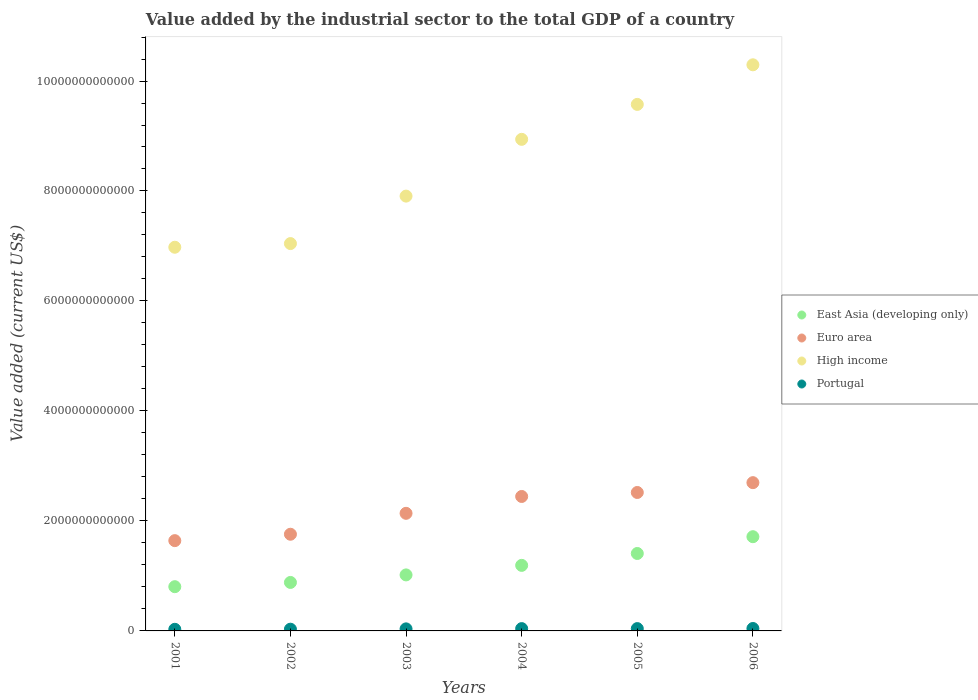What is the value added by the industrial sector to the total GDP in East Asia (developing only) in 2005?
Offer a very short reply. 1.41e+12. Across all years, what is the maximum value added by the industrial sector to the total GDP in Portugal?
Keep it short and to the point. 4.41e+1. Across all years, what is the minimum value added by the industrial sector to the total GDP in High income?
Provide a succinct answer. 6.98e+12. In which year was the value added by the industrial sector to the total GDP in Portugal maximum?
Offer a terse response. 2006. In which year was the value added by the industrial sector to the total GDP in Portugal minimum?
Your answer should be compact. 2001. What is the total value added by the industrial sector to the total GDP in East Asia (developing only) in the graph?
Offer a very short reply. 7.02e+12. What is the difference between the value added by the industrial sector to the total GDP in High income in 2003 and that in 2004?
Ensure brevity in your answer.  -1.03e+12. What is the difference between the value added by the industrial sector to the total GDP in East Asia (developing only) in 2004 and the value added by the industrial sector to the total GDP in High income in 2001?
Give a very brief answer. -5.78e+12. What is the average value added by the industrial sector to the total GDP in Portugal per year?
Ensure brevity in your answer.  3.77e+1. In the year 2003, what is the difference between the value added by the industrial sector to the total GDP in High income and value added by the industrial sector to the total GDP in Euro area?
Provide a succinct answer. 5.77e+12. In how many years, is the value added by the industrial sector to the total GDP in Portugal greater than 400000000000 US$?
Your answer should be compact. 0. What is the ratio of the value added by the industrial sector to the total GDP in Euro area in 2003 to that in 2005?
Give a very brief answer. 0.85. Is the value added by the industrial sector to the total GDP in Euro area in 2001 less than that in 2002?
Provide a short and direct response. Yes. What is the difference between the highest and the second highest value added by the industrial sector to the total GDP in Portugal?
Your answer should be very brief. 1.95e+09. What is the difference between the highest and the lowest value added by the industrial sector to the total GDP in High income?
Offer a terse response. 3.32e+12. Does the value added by the industrial sector to the total GDP in Portugal monotonically increase over the years?
Your answer should be compact. Yes. Is the value added by the industrial sector to the total GDP in East Asia (developing only) strictly less than the value added by the industrial sector to the total GDP in Portugal over the years?
Offer a very short reply. No. How many years are there in the graph?
Make the answer very short. 6. What is the difference between two consecutive major ticks on the Y-axis?
Offer a terse response. 2.00e+12. Does the graph contain any zero values?
Ensure brevity in your answer.  No. Where does the legend appear in the graph?
Your response must be concise. Center right. How many legend labels are there?
Provide a short and direct response. 4. How are the legend labels stacked?
Provide a short and direct response. Vertical. What is the title of the graph?
Offer a terse response. Value added by the industrial sector to the total GDP of a country. What is the label or title of the Y-axis?
Provide a succinct answer. Value added (current US$). What is the Value added (current US$) in East Asia (developing only) in 2001?
Offer a terse response. 8.04e+11. What is the Value added (current US$) in Euro area in 2001?
Provide a short and direct response. 1.64e+12. What is the Value added (current US$) of High income in 2001?
Provide a short and direct response. 6.98e+12. What is the Value added (current US$) of Portugal in 2001?
Your answer should be very brief. 2.93e+1. What is the Value added (current US$) in East Asia (developing only) in 2002?
Your answer should be compact. 8.82e+11. What is the Value added (current US$) of Euro area in 2002?
Your answer should be compact. 1.76e+12. What is the Value added (current US$) of High income in 2002?
Your response must be concise. 7.04e+12. What is the Value added (current US$) of Portugal in 2002?
Your answer should be very brief. 3.15e+1. What is the Value added (current US$) of East Asia (developing only) in 2003?
Your answer should be very brief. 1.02e+12. What is the Value added (current US$) in Euro area in 2003?
Keep it short and to the point. 2.14e+12. What is the Value added (current US$) in High income in 2003?
Your response must be concise. 7.91e+12. What is the Value added (current US$) of Portugal in 2003?
Your answer should be very brief. 3.73e+1. What is the Value added (current US$) of East Asia (developing only) in 2004?
Your answer should be very brief. 1.19e+12. What is the Value added (current US$) of Euro area in 2004?
Your response must be concise. 2.44e+12. What is the Value added (current US$) of High income in 2004?
Make the answer very short. 8.94e+12. What is the Value added (current US$) in Portugal in 2004?
Provide a succinct answer. 4.20e+1. What is the Value added (current US$) in East Asia (developing only) in 2005?
Your response must be concise. 1.41e+12. What is the Value added (current US$) in Euro area in 2005?
Your answer should be compact. 2.52e+12. What is the Value added (current US$) of High income in 2005?
Offer a terse response. 9.57e+12. What is the Value added (current US$) of Portugal in 2005?
Keep it short and to the point. 4.22e+1. What is the Value added (current US$) in East Asia (developing only) in 2006?
Give a very brief answer. 1.71e+12. What is the Value added (current US$) of Euro area in 2006?
Offer a terse response. 2.70e+12. What is the Value added (current US$) of High income in 2006?
Ensure brevity in your answer.  1.03e+13. What is the Value added (current US$) of Portugal in 2006?
Provide a short and direct response. 4.41e+1. Across all years, what is the maximum Value added (current US$) in East Asia (developing only)?
Provide a short and direct response. 1.71e+12. Across all years, what is the maximum Value added (current US$) in Euro area?
Ensure brevity in your answer.  2.70e+12. Across all years, what is the maximum Value added (current US$) in High income?
Keep it short and to the point. 1.03e+13. Across all years, what is the maximum Value added (current US$) in Portugal?
Keep it short and to the point. 4.41e+1. Across all years, what is the minimum Value added (current US$) of East Asia (developing only)?
Provide a succinct answer. 8.04e+11. Across all years, what is the minimum Value added (current US$) in Euro area?
Give a very brief answer. 1.64e+12. Across all years, what is the minimum Value added (current US$) in High income?
Provide a short and direct response. 6.98e+12. Across all years, what is the minimum Value added (current US$) in Portugal?
Ensure brevity in your answer.  2.93e+1. What is the total Value added (current US$) of East Asia (developing only) in the graph?
Provide a short and direct response. 7.02e+12. What is the total Value added (current US$) of Euro area in the graph?
Provide a short and direct response. 1.32e+13. What is the total Value added (current US$) in High income in the graph?
Keep it short and to the point. 5.07e+13. What is the total Value added (current US$) in Portugal in the graph?
Provide a succinct answer. 2.26e+11. What is the difference between the Value added (current US$) in East Asia (developing only) in 2001 and that in 2002?
Give a very brief answer. -7.72e+1. What is the difference between the Value added (current US$) in Euro area in 2001 and that in 2002?
Your response must be concise. -1.16e+11. What is the difference between the Value added (current US$) in High income in 2001 and that in 2002?
Make the answer very short. -6.67e+1. What is the difference between the Value added (current US$) of Portugal in 2001 and that in 2002?
Give a very brief answer. -2.19e+09. What is the difference between the Value added (current US$) in East Asia (developing only) in 2001 and that in 2003?
Offer a terse response. -2.14e+11. What is the difference between the Value added (current US$) of Euro area in 2001 and that in 2003?
Your response must be concise. -4.97e+11. What is the difference between the Value added (current US$) in High income in 2001 and that in 2003?
Ensure brevity in your answer.  -9.30e+11. What is the difference between the Value added (current US$) in Portugal in 2001 and that in 2003?
Ensure brevity in your answer.  -7.97e+09. What is the difference between the Value added (current US$) of East Asia (developing only) in 2001 and that in 2004?
Ensure brevity in your answer.  -3.88e+11. What is the difference between the Value added (current US$) of Euro area in 2001 and that in 2004?
Keep it short and to the point. -8.03e+11. What is the difference between the Value added (current US$) in High income in 2001 and that in 2004?
Ensure brevity in your answer.  -1.96e+12. What is the difference between the Value added (current US$) in Portugal in 2001 and that in 2004?
Your answer should be very brief. -1.27e+1. What is the difference between the Value added (current US$) of East Asia (developing only) in 2001 and that in 2005?
Your answer should be compact. -6.04e+11. What is the difference between the Value added (current US$) of Euro area in 2001 and that in 2005?
Your answer should be compact. -8.76e+11. What is the difference between the Value added (current US$) of High income in 2001 and that in 2005?
Offer a terse response. -2.60e+12. What is the difference between the Value added (current US$) in Portugal in 2001 and that in 2005?
Offer a very short reply. -1.28e+1. What is the difference between the Value added (current US$) of East Asia (developing only) in 2001 and that in 2006?
Provide a short and direct response. -9.09e+11. What is the difference between the Value added (current US$) in Euro area in 2001 and that in 2006?
Provide a succinct answer. -1.05e+12. What is the difference between the Value added (current US$) of High income in 2001 and that in 2006?
Keep it short and to the point. -3.32e+12. What is the difference between the Value added (current US$) in Portugal in 2001 and that in 2006?
Keep it short and to the point. -1.48e+1. What is the difference between the Value added (current US$) of East Asia (developing only) in 2002 and that in 2003?
Your answer should be very brief. -1.37e+11. What is the difference between the Value added (current US$) of Euro area in 2002 and that in 2003?
Offer a terse response. -3.80e+11. What is the difference between the Value added (current US$) in High income in 2002 and that in 2003?
Your answer should be very brief. -8.63e+11. What is the difference between the Value added (current US$) in Portugal in 2002 and that in 2003?
Ensure brevity in your answer.  -5.78e+09. What is the difference between the Value added (current US$) of East Asia (developing only) in 2002 and that in 2004?
Give a very brief answer. -3.10e+11. What is the difference between the Value added (current US$) in Euro area in 2002 and that in 2004?
Give a very brief answer. -6.87e+11. What is the difference between the Value added (current US$) in High income in 2002 and that in 2004?
Your response must be concise. -1.90e+12. What is the difference between the Value added (current US$) in Portugal in 2002 and that in 2004?
Give a very brief answer. -1.05e+1. What is the difference between the Value added (current US$) in East Asia (developing only) in 2002 and that in 2005?
Offer a very short reply. -5.27e+11. What is the difference between the Value added (current US$) of Euro area in 2002 and that in 2005?
Provide a succinct answer. -7.59e+11. What is the difference between the Value added (current US$) in High income in 2002 and that in 2005?
Make the answer very short. -2.53e+12. What is the difference between the Value added (current US$) of Portugal in 2002 and that in 2005?
Your response must be concise. -1.06e+1. What is the difference between the Value added (current US$) of East Asia (developing only) in 2002 and that in 2006?
Provide a succinct answer. -8.32e+11. What is the difference between the Value added (current US$) in Euro area in 2002 and that in 2006?
Make the answer very short. -9.38e+11. What is the difference between the Value added (current US$) of High income in 2002 and that in 2006?
Offer a very short reply. -3.25e+12. What is the difference between the Value added (current US$) of Portugal in 2002 and that in 2006?
Provide a short and direct response. -1.26e+1. What is the difference between the Value added (current US$) in East Asia (developing only) in 2003 and that in 2004?
Your answer should be very brief. -1.73e+11. What is the difference between the Value added (current US$) in Euro area in 2003 and that in 2004?
Your response must be concise. -3.06e+11. What is the difference between the Value added (current US$) in High income in 2003 and that in 2004?
Your response must be concise. -1.03e+12. What is the difference between the Value added (current US$) in Portugal in 2003 and that in 2004?
Provide a short and direct response. -4.73e+09. What is the difference between the Value added (current US$) of East Asia (developing only) in 2003 and that in 2005?
Provide a succinct answer. -3.90e+11. What is the difference between the Value added (current US$) of Euro area in 2003 and that in 2005?
Offer a terse response. -3.79e+11. What is the difference between the Value added (current US$) in High income in 2003 and that in 2005?
Make the answer very short. -1.67e+12. What is the difference between the Value added (current US$) of Portugal in 2003 and that in 2005?
Provide a short and direct response. -4.85e+09. What is the difference between the Value added (current US$) in East Asia (developing only) in 2003 and that in 2006?
Your response must be concise. -6.95e+11. What is the difference between the Value added (current US$) in Euro area in 2003 and that in 2006?
Offer a very short reply. -5.58e+11. What is the difference between the Value added (current US$) in High income in 2003 and that in 2006?
Make the answer very short. -2.39e+12. What is the difference between the Value added (current US$) of Portugal in 2003 and that in 2006?
Offer a very short reply. -6.80e+09. What is the difference between the Value added (current US$) in East Asia (developing only) in 2004 and that in 2005?
Keep it short and to the point. -2.16e+11. What is the difference between the Value added (current US$) in Euro area in 2004 and that in 2005?
Offer a very short reply. -7.26e+1. What is the difference between the Value added (current US$) in High income in 2004 and that in 2005?
Provide a succinct answer. -6.35e+11. What is the difference between the Value added (current US$) in Portugal in 2004 and that in 2005?
Your answer should be compact. -1.28e+08. What is the difference between the Value added (current US$) in East Asia (developing only) in 2004 and that in 2006?
Provide a short and direct response. -5.21e+11. What is the difference between the Value added (current US$) in Euro area in 2004 and that in 2006?
Provide a short and direct response. -2.51e+11. What is the difference between the Value added (current US$) in High income in 2004 and that in 2006?
Provide a succinct answer. -1.36e+12. What is the difference between the Value added (current US$) in Portugal in 2004 and that in 2006?
Your response must be concise. -2.07e+09. What is the difference between the Value added (current US$) in East Asia (developing only) in 2005 and that in 2006?
Offer a very short reply. -3.05e+11. What is the difference between the Value added (current US$) in Euro area in 2005 and that in 2006?
Provide a succinct answer. -1.79e+11. What is the difference between the Value added (current US$) in High income in 2005 and that in 2006?
Offer a very short reply. -7.20e+11. What is the difference between the Value added (current US$) of Portugal in 2005 and that in 2006?
Your answer should be very brief. -1.95e+09. What is the difference between the Value added (current US$) in East Asia (developing only) in 2001 and the Value added (current US$) in Euro area in 2002?
Make the answer very short. -9.54e+11. What is the difference between the Value added (current US$) in East Asia (developing only) in 2001 and the Value added (current US$) in High income in 2002?
Provide a short and direct response. -6.24e+12. What is the difference between the Value added (current US$) in East Asia (developing only) in 2001 and the Value added (current US$) in Portugal in 2002?
Your answer should be very brief. 7.73e+11. What is the difference between the Value added (current US$) of Euro area in 2001 and the Value added (current US$) of High income in 2002?
Your response must be concise. -5.40e+12. What is the difference between the Value added (current US$) of Euro area in 2001 and the Value added (current US$) of Portugal in 2002?
Provide a succinct answer. 1.61e+12. What is the difference between the Value added (current US$) in High income in 2001 and the Value added (current US$) in Portugal in 2002?
Your answer should be very brief. 6.95e+12. What is the difference between the Value added (current US$) in East Asia (developing only) in 2001 and the Value added (current US$) in Euro area in 2003?
Provide a short and direct response. -1.33e+12. What is the difference between the Value added (current US$) in East Asia (developing only) in 2001 and the Value added (current US$) in High income in 2003?
Provide a succinct answer. -7.10e+12. What is the difference between the Value added (current US$) of East Asia (developing only) in 2001 and the Value added (current US$) of Portugal in 2003?
Ensure brevity in your answer.  7.67e+11. What is the difference between the Value added (current US$) in Euro area in 2001 and the Value added (current US$) in High income in 2003?
Provide a succinct answer. -6.27e+12. What is the difference between the Value added (current US$) in Euro area in 2001 and the Value added (current US$) in Portugal in 2003?
Your response must be concise. 1.60e+12. What is the difference between the Value added (current US$) in High income in 2001 and the Value added (current US$) in Portugal in 2003?
Your answer should be very brief. 6.94e+12. What is the difference between the Value added (current US$) of East Asia (developing only) in 2001 and the Value added (current US$) of Euro area in 2004?
Give a very brief answer. -1.64e+12. What is the difference between the Value added (current US$) of East Asia (developing only) in 2001 and the Value added (current US$) of High income in 2004?
Your answer should be very brief. -8.13e+12. What is the difference between the Value added (current US$) in East Asia (developing only) in 2001 and the Value added (current US$) in Portugal in 2004?
Your answer should be very brief. 7.62e+11. What is the difference between the Value added (current US$) in Euro area in 2001 and the Value added (current US$) in High income in 2004?
Provide a short and direct response. -7.30e+12. What is the difference between the Value added (current US$) of Euro area in 2001 and the Value added (current US$) of Portugal in 2004?
Make the answer very short. 1.60e+12. What is the difference between the Value added (current US$) in High income in 2001 and the Value added (current US$) in Portugal in 2004?
Keep it short and to the point. 6.93e+12. What is the difference between the Value added (current US$) in East Asia (developing only) in 2001 and the Value added (current US$) in Euro area in 2005?
Make the answer very short. -1.71e+12. What is the difference between the Value added (current US$) in East Asia (developing only) in 2001 and the Value added (current US$) in High income in 2005?
Provide a short and direct response. -8.77e+12. What is the difference between the Value added (current US$) of East Asia (developing only) in 2001 and the Value added (current US$) of Portugal in 2005?
Make the answer very short. 7.62e+11. What is the difference between the Value added (current US$) in Euro area in 2001 and the Value added (current US$) in High income in 2005?
Ensure brevity in your answer.  -7.93e+12. What is the difference between the Value added (current US$) of Euro area in 2001 and the Value added (current US$) of Portugal in 2005?
Offer a terse response. 1.60e+12. What is the difference between the Value added (current US$) of High income in 2001 and the Value added (current US$) of Portugal in 2005?
Your answer should be very brief. 6.93e+12. What is the difference between the Value added (current US$) of East Asia (developing only) in 2001 and the Value added (current US$) of Euro area in 2006?
Make the answer very short. -1.89e+12. What is the difference between the Value added (current US$) in East Asia (developing only) in 2001 and the Value added (current US$) in High income in 2006?
Provide a short and direct response. -9.49e+12. What is the difference between the Value added (current US$) in East Asia (developing only) in 2001 and the Value added (current US$) in Portugal in 2006?
Your answer should be compact. 7.60e+11. What is the difference between the Value added (current US$) of Euro area in 2001 and the Value added (current US$) of High income in 2006?
Ensure brevity in your answer.  -8.65e+12. What is the difference between the Value added (current US$) in Euro area in 2001 and the Value added (current US$) in Portugal in 2006?
Keep it short and to the point. 1.60e+12. What is the difference between the Value added (current US$) of High income in 2001 and the Value added (current US$) of Portugal in 2006?
Offer a terse response. 6.93e+12. What is the difference between the Value added (current US$) of East Asia (developing only) in 2002 and the Value added (current US$) of Euro area in 2003?
Your answer should be compact. -1.26e+12. What is the difference between the Value added (current US$) of East Asia (developing only) in 2002 and the Value added (current US$) of High income in 2003?
Make the answer very short. -7.03e+12. What is the difference between the Value added (current US$) of East Asia (developing only) in 2002 and the Value added (current US$) of Portugal in 2003?
Offer a terse response. 8.44e+11. What is the difference between the Value added (current US$) in Euro area in 2002 and the Value added (current US$) in High income in 2003?
Give a very brief answer. -6.15e+12. What is the difference between the Value added (current US$) in Euro area in 2002 and the Value added (current US$) in Portugal in 2003?
Make the answer very short. 1.72e+12. What is the difference between the Value added (current US$) of High income in 2002 and the Value added (current US$) of Portugal in 2003?
Offer a very short reply. 7.01e+12. What is the difference between the Value added (current US$) in East Asia (developing only) in 2002 and the Value added (current US$) in Euro area in 2004?
Provide a short and direct response. -1.56e+12. What is the difference between the Value added (current US$) of East Asia (developing only) in 2002 and the Value added (current US$) of High income in 2004?
Make the answer very short. -8.06e+12. What is the difference between the Value added (current US$) of East Asia (developing only) in 2002 and the Value added (current US$) of Portugal in 2004?
Offer a very short reply. 8.40e+11. What is the difference between the Value added (current US$) of Euro area in 2002 and the Value added (current US$) of High income in 2004?
Offer a terse response. -7.18e+12. What is the difference between the Value added (current US$) in Euro area in 2002 and the Value added (current US$) in Portugal in 2004?
Your response must be concise. 1.72e+12. What is the difference between the Value added (current US$) of High income in 2002 and the Value added (current US$) of Portugal in 2004?
Offer a terse response. 7.00e+12. What is the difference between the Value added (current US$) of East Asia (developing only) in 2002 and the Value added (current US$) of Euro area in 2005?
Provide a short and direct response. -1.64e+12. What is the difference between the Value added (current US$) in East Asia (developing only) in 2002 and the Value added (current US$) in High income in 2005?
Offer a very short reply. -8.69e+12. What is the difference between the Value added (current US$) in East Asia (developing only) in 2002 and the Value added (current US$) in Portugal in 2005?
Provide a succinct answer. 8.39e+11. What is the difference between the Value added (current US$) of Euro area in 2002 and the Value added (current US$) of High income in 2005?
Offer a terse response. -7.82e+12. What is the difference between the Value added (current US$) in Euro area in 2002 and the Value added (current US$) in Portugal in 2005?
Offer a very short reply. 1.72e+12. What is the difference between the Value added (current US$) of High income in 2002 and the Value added (current US$) of Portugal in 2005?
Offer a very short reply. 7.00e+12. What is the difference between the Value added (current US$) in East Asia (developing only) in 2002 and the Value added (current US$) in Euro area in 2006?
Provide a succinct answer. -1.81e+12. What is the difference between the Value added (current US$) in East Asia (developing only) in 2002 and the Value added (current US$) in High income in 2006?
Your answer should be compact. -9.41e+12. What is the difference between the Value added (current US$) in East Asia (developing only) in 2002 and the Value added (current US$) in Portugal in 2006?
Give a very brief answer. 8.38e+11. What is the difference between the Value added (current US$) in Euro area in 2002 and the Value added (current US$) in High income in 2006?
Provide a short and direct response. -8.54e+12. What is the difference between the Value added (current US$) in Euro area in 2002 and the Value added (current US$) in Portugal in 2006?
Offer a terse response. 1.71e+12. What is the difference between the Value added (current US$) of High income in 2002 and the Value added (current US$) of Portugal in 2006?
Ensure brevity in your answer.  7.00e+12. What is the difference between the Value added (current US$) of East Asia (developing only) in 2003 and the Value added (current US$) of Euro area in 2004?
Provide a succinct answer. -1.43e+12. What is the difference between the Value added (current US$) of East Asia (developing only) in 2003 and the Value added (current US$) of High income in 2004?
Your answer should be very brief. -7.92e+12. What is the difference between the Value added (current US$) in East Asia (developing only) in 2003 and the Value added (current US$) in Portugal in 2004?
Your answer should be very brief. 9.77e+11. What is the difference between the Value added (current US$) in Euro area in 2003 and the Value added (current US$) in High income in 2004?
Your answer should be very brief. -6.80e+12. What is the difference between the Value added (current US$) in Euro area in 2003 and the Value added (current US$) in Portugal in 2004?
Give a very brief answer. 2.10e+12. What is the difference between the Value added (current US$) in High income in 2003 and the Value added (current US$) in Portugal in 2004?
Provide a succinct answer. 7.87e+12. What is the difference between the Value added (current US$) in East Asia (developing only) in 2003 and the Value added (current US$) in Euro area in 2005?
Offer a terse response. -1.50e+12. What is the difference between the Value added (current US$) of East Asia (developing only) in 2003 and the Value added (current US$) of High income in 2005?
Provide a short and direct response. -8.56e+12. What is the difference between the Value added (current US$) in East Asia (developing only) in 2003 and the Value added (current US$) in Portugal in 2005?
Your answer should be very brief. 9.76e+11. What is the difference between the Value added (current US$) in Euro area in 2003 and the Value added (current US$) in High income in 2005?
Your answer should be compact. -7.44e+12. What is the difference between the Value added (current US$) of Euro area in 2003 and the Value added (current US$) of Portugal in 2005?
Keep it short and to the point. 2.10e+12. What is the difference between the Value added (current US$) of High income in 2003 and the Value added (current US$) of Portugal in 2005?
Your answer should be compact. 7.86e+12. What is the difference between the Value added (current US$) in East Asia (developing only) in 2003 and the Value added (current US$) in Euro area in 2006?
Give a very brief answer. -1.68e+12. What is the difference between the Value added (current US$) of East Asia (developing only) in 2003 and the Value added (current US$) of High income in 2006?
Make the answer very short. -9.28e+12. What is the difference between the Value added (current US$) of East Asia (developing only) in 2003 and the Value added (current US$) of Portugal in 2006?
Offer a terse response. 9.74e+11. What is the difference between the Value added (current US$) in Euro area in 2003 and the Value added (current US$) in High income in 2006?
Keep it short and to the point. -8.16e+12. What is the difference between the Value added (current US$) of Euro area in 2003 and the Value added (current US$) of Portugal in 2006?
Make the answer very short. 2.09e+12. What is the difference between the Value added (current US$) in High income in 2003 and the Value added (current US$) in Portugal in 2006?
Your answer should be very brief. 7.86e+12. What is the difference between the Value added (current US$) in East Asia (developing only) in 2004 and the Value added (current US$) in Euro area in 2005?
Offer a terse response. -1.33e+12. What is the difference between the Value added (current US$) in East Asia (developing only) in 2004 and the Value added (current US$) in High income in 2005?
Ensure brevity in your answer.  -8.38e+12. What is the difference between the Value added (current US$) in East Asia (developing only) in 2004 and the Value added (current US$) in Portugal in 2005?
Your answer should be very brief. 1.15e+12. What is the difference between the Value added (current US$) of Euro area in 2004 and the Value added (current US$) of High income in 2005?
Provide a succinct answer. -7.13e+12. What is the difference between the Value added (current US$) of Euro area in 2004 and the Value added (current US$) of Portugal in 2005?
Make the answer very short. 2.40e+12. What is the difference between the Value added (current US$) in High income in 2004 and the Value added (current US$) in Portugal in 2005?
Ensure brevity in your answer.  8.90e+12. What is the difference between the Value added (current US$) in East Asia (developing only) in 2004 and the Value added (current US$) in Euro area in 2006?
Ensure brevity in your answer.  -1.50e+12. What is the difference between the Value added (current US$) in East Asia (developing only) in 2004 and the Value added (current US$) in High income in 2006?
Your answer should be compact. -9.10e+12. What is the difference between the Value added (current US$) in East Asia (developing only) in 2004 and the Value added (current US$) in Portugal in 2006?
Ensure brevity in your answer.  1.15e+12. What is the difference between the Value added (current US$) in Euro area in 2004 and the Value added (current US$) in High income in 2006?
Offer a very short reply. -7.85e+12. What is the difference between the Value added (current US$) of Euro area in 2004 and the Value added (current US$) of Portugal in 2006?
Ensure brevity in your answer.  2.40e+12. What is the difference between the Value added (current US$) of High income in 2004 and the Value added (current US$) of Portugal in 2006?
Offer a terse response. 8.90e+12. What is the difference between the Value added (current US$) in East Asia (developing only) in 2005 and the Value added (current US$) in Euro area in 2006?
Offer a terse response. -1.29e+12. What is the difference between the Value added (current US$) of East Asia (developing only) in 2005 and the Value added (current US$) of High income in 2006?
Offer a terse response. -8.89e+12. What is the difference between the Value added (current US$) of East Asia (developing only) in 2005 and the Value added (current US$) of Portugal in 2006?
Make the answer very short. 1.36e+12. What is the difference between the Value added (current US$) in Euro area in 2005 and the Value added (current US$) in High income in 2006?
Your answer should be very brief. -7.78e+12. What is the difference between the Value added (current US$) in Euro area in 2005 and the Value added (current US$) in Portugal in 2006?
Give a very brief answer. 2.47e+12. What is the difference between the Value added (current US$) of High income in 2005 and the Value added (current US$) of Portugal in 2006?
Your response must be concise. 9.53e+12. What is the average Value added (current US$) in East Asia (developing only) per year?
Keep it short and to the point. 1.17e+12. What is the average Value added (current US$) in Euro area per year?
Give a very brief answer. 2.20e+12. What is the average Value added (current US$) in High income per year?
Keep it short and to the point. 8.46e+12. What is the average Value added (current US$) of Portugal per year?
Make the answer very short. 3.77e+1. In the year 2001, what is the difference between the Value added (current US$) of East Asia (developing only) and Value added (current US$) of Euro area?
Your response must be concise. -8.37e+11. In the year 2001, what is the difference between the Value added (current US$) in East Asia (developing only) and Value added (current US$) in High income?
Make the answer very short. -6.17e+12. In the year 2001, what is the difference between the Value added (current US$) of East Asia (developing only) and Value added (current US$) of Portugal?
Provide a short and direct response. 7.75e+11. In the year 2001, what is the difference between the Value added (current US$) of Euro area and Value added (current US$) of High income?
Provide a short and direct response. -5.34e+12. In the year 2001, what is the difference between the Value added (current US$) of Euro area and Value added (current US$) of Portugal?
Provide a succinct answer. 1.61e+12. In the year 2001, what is the difference between the Value added (current US$) in High income and Value added (current US$) in Portugal?
Provide a succinct answer. 6.95e+12. In the year 2002, what is the difference between the Value added (current US$) of East Asia (developing only) and Value added (current US$) of Euro area?
Offer a terse response. -8.76e+11. In the year 2002, what is the difference between the Value added (current US$) in East Asia (developing only) and Value added (current US$) in High income?
Ensure brevity in your answer.  -6.16e+12. In the year 2002, what is the difference between the Value added (current US$) of East Asia (developing only) and Value added (current US$) of Portugal?
Make the answer very short. 8.50e+11. In the year 2002, what is the difference between the Value added (current US$) of Euro area and Value added (current US$) of High income?
Make the answer very short. -5.29e+12. In the year 2002, what is the difference between the Value added (current US$) in Euro area and Value added (current US$) in Portugal?
Your answer should be very brief. 1.73e+12. In the year 2002, what is the difference between the Value added (current US$) of High income and Value added (current US$) of Portugal?
Offer a terse response. 7.01e+12. In the year 2003, what is the difference between the Value added (current US$) of East Asia (developing only) and Value added (current US$) of Euro area?
Your answer should be very brief. -1.12e+12. In the year 2003, what is the difference between the Value added (current US$) in East Asia (developing only) and Value added (current US$) in High income?
Provide a short and direct response. -6.89e+12. In the year 2003, what is the difference between the Value added (current US$) of East Asia (developing only) and Value added (current US$) of Portugal?
Provide a short and direct response. 9.81e+11. In the year 2003, what is the difference between the Value added (current US$) in Euro area and Value added (current US$) in High income?
Provide a short and direct response. -5.77e+12. In the year 2003, what is the difference between the Value added (current US$) of Euro area and Value added (current US$) of Portugal?
Give a very brief answer. 2.10e+12. In the year 2003, what is the difference between the Value added (current US$) of High income and Value added (current US$) of Portugal?
Offer a terse response. 7.87e+12. In the year 2004, what is the difference between the Value added (current US$) of East Asia (developing only) and Value added (current US$) of Euro area?
Offer a very short reply. -1.25e+12. In the year 2004, what is the difference between the Value added (current US$) of East Asia (developing only) and Value added (current US$) of High income?
Your answer should be compact. -7.75e+12. In the year 2004, what is the difference between the Value added (current US$) of East Asia (developing only) and Value added (current US$) of Portugal?
Make the answer very short. 1.15e+12. In the year 2004, what is the difference between the Value added (current US$) in Euro area and Value added (current US$) in High income?
Ensure brevity in your answer.  -6.49e+12. In the year 2004, what is the difference between the Value added (current US$) of Euro area and Value added (current US$) of Portugal?
Your response must be concise. 2.40e+12. In the year 2004, what is the difference between the Value added (current US$) in High income and Value added (current US$) in Portugal?
Offer a very short reply. 8.90e+12. In the year 2005, what is the difference between the Value added (current US$) of East Asia (developing only) and Value added (current US$) of Euro area?
Ensure brevity in your answer.  -1.11e+12. In the year 2005, what is the difference between the Value added (current US$) of East Asia (developing only) and Value added (current US$) of High income?
Ensure brevity in your answer.  -8.17e+12. In the year 2005, what is the difference between the Value added (current US$) of East Asia (developing only) and Value added (current US$) of Portugal?
Your answer should be very brief. 1.37e+12. In the year 2005, what is the difference between the Value added (current US$) in Euro area and Value added (current US$) in High income?
Offer a very short reply. -7.06e+12. In the year 2005, what is the difference between the Value added (current US$) of Euro area and Value added (current US$) of Portugal?
Ensure brevity in your answer.  2.48e+12. In the year 2005, what is the difference between the Value added (current US$) of High income and Value added (current US$) of Portugal?
Ensure brevity in your answer.  9.53e+12. In the year 2006, what is the difference between the Value added (current US$) of East Asia (developing only) and Value added (current US$) of Euro area?
Keep it short and to the point. -9.83e+11. In the year 2006, what is the difference between the Value added (current US$) in East Asia (developing only) and Value added (current US$) in High income?
Provide a succinct answer. -8.58e+12. In the year 2006, what is the difference between the Value added (current US$) in East Asia (developing only) and Value added (current US$) in Portugal?
Give a very brief answer. 1.67e+12. In the year 2006, what is the difference between the Value added (current US$) of Euro area and Value added (current US$) of High income?
Offer a terse response. -7.60e+12. In the year 2006, what is the difference between the Value added (current US$) in Euro area and Value added (current US$) in Portugal?
Provide a succinct answer. 2.65e+12. In the year 2006, what is the difference between the Value added (current US$) of High income and Value added (current US$) of Portugal?
Provide a succinct answer. 1.03e+13. What is the ratio of the Value added (current US$) in East Asia (developing only) in 2001 to that in 2002?
Provide a short and direct response. 0.91. What is the ratio of the Value added (current US$) of Euro area in 2001 to that in 2002?
Offer a very short reply. 0.93. What is the ratio of the Value added (current US$) of High income in 2001 to that in 2002?
Provide a succinct answer. 0.99. What is the ratio of the Value added (current US$) of Portugal in 2001 to that in 2002?
Offer a terse response. 0.93. What is the ratio of the Value added (current US$) of East Asia (developing only) in 2001 to that in 2003?
Your answer should be very brief. 0.79. What is the ratio of the Value added (current US$) in Euro area in 2001 to that in 2003?
Your response must be concise. 0.77. What is the ratio of the Value added (current US$) in High income in 2001 to that in 2003?
Provide a succinct answer. 0.88. What is the ratio of the Value added (current US$) of Portugal in 2001 to that in 2003?
Ensure brevity in your answer.  0.79. What is the ratio of the Value added (current US$) of East Asia (developing only) in 2001 to that in 2004?
Provide a succinct answer. 0.67. What is the ratio of the Value added (current US$) of Euro area in 2001 to that in 2004?
Keep it short and to the point. 0.67. What is the ratio of the Value added (current US$) of High income in 2001 to that in 2004?
Provide a succinct answer. 0.78. What is the ratio of the Value added (current US$) of Portugal in 2001 to that in 2004?
Your response must be concise. 0.7. What is the ratio of the Value added (current US$) in East Asia (developing only) in 2001 to that in 2005?
Provide a short and direct response. 0.57. What is the ratio of the Value added (current US$) in Euro area in 2001 to that in 2005?
Your answer should be very brief. 0.65. What is the ratio of the Value added (current US$) in High income in 2001 to that in 2005?
Provide a short and direct response. 0.73. What is the ratio of the Value added (current US$) in Portugal in 2001 to that in 2005?
Offer a very short reply. 0.7. What is the ratio of the Value added (current US$) of East Asia (developing only) in 2001 to that in 2006?
Your answer should be very brief. 0.47. What is the ratio of the Value added (current US$) in Euro area in 2001 to that in 2006?
Ensure brevity in your answer.  0.61. What is the ratio of the Value added (current US$) of High income in 2001 to that in 2006?
Your answer should be compact. 0.68. What is the ratio of the Value added (current US$) in Portugal in 2001 to that in 2006?
Make the answer very short. 0.67. What is the ratio of the Value added (current US$) of East Asia (developing only) in 2002 to that in 2003?
Keep it short and to the point. 0.87. What is the ratio of the Value added (current US$) of Euro area in 2002 to that in 2003?
Provide a short and direct response. 0.82. What is the ratio of the Value added (current US$) of High income in 2002 to that in 2003?
Provide a succinct answer. 0.89. What is the ratio of the Value added (current US$) in Portugal in 2002 to that in 2003?
Give a very brief answer. 0.84. What is the ratio of the Value added (current US$) of East Asia (developing only) in 2002 to that in 2004?
Keep it short and to the point. 0.74. What is the ratio of the Value added (current US$) in Euro area in 2002 to that in 2004?
Your answer should be compact. 0.72. What is the ratio of the Value added (current US$) in High income in 2002 to that in 2004?
Make the answer very short. 0.79. What is the ratio of the Value added (current US$) of Portugal in 2002 to that in 2004?
Offer a terse response. 0.75. What is the ratio of the Value added (current US$) in East Asia (developing only) in 2002 to that in 2005?
Offer a terse response. 0.63. What is the ratio of the Value added (current US$) in Euro area in 2002 to that in 2005?
Your response must be concise. 0.7. What is the ratio of the Value added (current US$) of High income in 2002 to that in 2005?
Your answer should be very brief. 0.74. What is the ratio of the Value added (current US$) of Portugal in 2002 to that in 2005?
Your answer should be compact. 0.75. What is the ratio of the Value added (current US$) in East Asia (developing only) in 2002 to that in 2006?
Offer a terse response. 0.51. What is the ratio of the Value added (current US$) of Euro area in 2002 to that in 2006?
Provide a succinct answer. 0.65. What is the ratio of the Value added (current US$) of High income in 2002 to that in 2006?
Your response must be concise. 0.68. What is the ratio of the Value added (current US$) of Portugal in 2002 to that in 2006?
Provide a short and direct response. 0.71. What is the ratio of the Value added (current US$) in East Asia (developing only) in 2003 to that in 2004?
Your answer should be compact. 0.85. What is the ratio of the Value added (current US$) of Euro area in 2003 to that in 2004?
Offer a very short reply. 0.87. What is the ratio of the Value added (current US$) of High income in 2003 to that in 2004?
Your answer should be very brief. 0.88. What is the ratio of the Value added (current US$) in Portugal in 2003 to that in 2004?
Keep it short and to the point. 0.89. What is the ratio of the Value added (current US$) in East Asia (developing only) in 2003 to that in 2005?
Your answer should be compact. 0.72. What is the ratio of the Value added (current US$) of Euro area in 2003 to that in 2005?
Your response must be concise. 0.85. What is the ratio of the Value added (current US$) of High income in 2003 to that in 2005?
Your answer should be very brief. 0.83. What is the ratio of the Value added (current US$) of Portugal in 2003 to that in 2005?
Your answer should be compact. 0.88. What is the ratio of the Value added (current US$) of East Asia (developing only) in 2003 to that in 2006?
Your response must be concise. 0.59. What is the ratio of the Value added (current US$) of Euro area in 2003 to that in 2006?
Ensure brevity in your answer.  0.79. What is the ratio of the Value added (current US$) in High income in 2003 to that in 2006?
Offer a terse response. 0.77. What is the ratio of the Value added (current US$) in Portugal in 2003 to that in 2006?
Keep it short and to the point. 0.85. What is the ratio of the Value added (current US$) of East Asia (developing only) in 2004 to that in 2005?
Give a very brief answer. 0.85. What is the ratio of the Value added (current US$) in Euro area in 2004 to that in 2005?
Your answer should be compact. 0.97. What is the ratio of the Value added (current US$) in High income in 2004 to that in 2005?
Your answer should be compact. 0.93. What is the ratio of the Value added (current US$) in East Asia (developing only) in 2004 to that in 2006?
Make the answer very short. 0.7. What is the ratio of the Value added (current US$) of Euro area in 2004 to that in 2006?
Make the answer very short. 0.91. What is the ratio of the Value added (current US$) in High income in 2004 to that in 2006?
Make the answer very short. 0.87. What is the ratio of the Value added (current US$) of Portugal in 2004 to that in 2006?
Your answer should be compact. 0.95. What is the ratio of the Value added (current US$) in East Asia (developing only) in 2005 to that in 2006?
Offer a very short reply. 0.82. What is the ratio of the Value added (current US$) of Euro area in 2005 to that in 2006?
Offer a terse response. 0.93. What is the ratio of the Value added (current US$) in High income in 2005 to that in 2006?
Offer a terse response. 0.93. What is the ratio of the Value added (current US$) of Portugal in 2005 to that in 2006?
Keep it short and to the point. 0.96. What is the difference between the highest and the second highest Value added (current US$) in East Asia (developing only)?
Keep it short and to the point. 3.05e+11. What is the difference between the highest and the second highest Value added (current US$) in Euro area?
Make the answer very short. 1.79e+11. What is the difference between the highest and the second highest Value added (current US$) in High income?
Your answer should be compact. 7.20e+11. What is the difference between the highest and the second highest Value added (current US$) of Portugal?
Offer a terse response. 1.95e+09. What is the difference between the highest and the lowest Value added (current US$) of East Asia (developing only)?
Provide a succinct answer. 9.09e+11. What is the difference between the highest and the lowest Value added (current US$) in Euro area?
Provide a short and direct response. 1.05e+12. What is the difference between the highest and the lowest Value added (current US$) of High income?
Your answer should be compact. 3.32e+12. What is the difference between the highest and the lowest Value added (current US$) in Portugal?
Your answer should be very brief. 1.48e+1. 